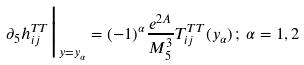Convert formula to latex. <formula><loc_0><loc_0><loc_500><loc_500>\partial _ { 5 } h _ { i j } ^ { T T } \Big | _ { y = y _ { \alpha } } = ( - 1 ) ^ { \alpha } \frac { e ^ { 2 A } } { M _ { 5 } ^ { 3 } } T _ { i j } ^ { T T } ( y _ { \alpha } ) \, ; \, \alpha = 1 , 2</formula> 